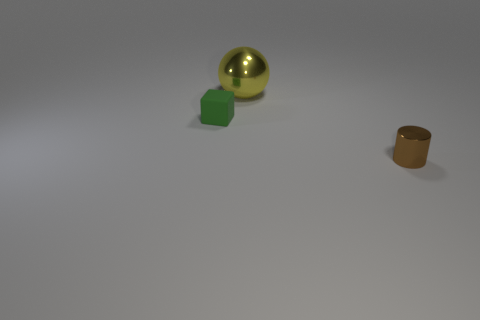Is there anything else that has the same material as the block?
Offer a terse response. No. Is there any other thing that has the same shape as the big metal thing?
Make the answer very short. No. What material is the big thing?
Your answer should be compact. Metal. How many other things are there of the same material as the sphere?
Provide a short and direct response. 1. Does the cylinder have the same material as the small object that is behind the small cylinder?
Provide a succinct answer. No. Are there fewer yellow shiny spheres that are behind the cube than things that are in front of the yellow sphere?
Ensure brevity in your answer.  Yes. What color is the ball behind the small block?
Offer a very short reply. Yellow. There is a green rubber block that is to the left of the yellow metallic thing; does it have the same size as the tiny brown shiny cylinder?
Your answer should be compact. Yes. What number of shiny cylinders are on the right side of the small cube?
Give a very brief answer. 1. Are there any other balls of the same size as the yellow metal sphere?
Give a very brief answer. No. 